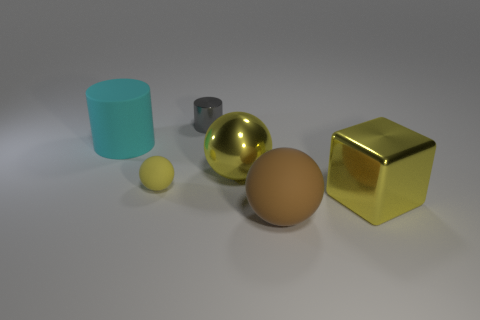How many things are either small objects that are behind the cyan thing or rubber objects that are to the right of the yellow shiny sphere?
Provide a short and direct response. 2. Are there an equal number of large cyan cylinders to the right of the block and large blocks that are on the right side of the brown thing?
Your answer should be compact. No. There is a big ball in front of the large block; what is its color?
Your answer should be compact. Brown. There is a small matte ball; is it the same color as the large metal thing right of the big yellow ball?
Make the answer very short. Yes. Are there fewer yellow metallic spheres than big cyan spheres?
Your answer should be very brief. No. There is a ball that is on the left side of the gray shiny object; does it have the same color as the large shiny block?
Offer a very short reply. Yes. What number of cyan rubber objects are the same size as the brown ball?
Ensure brevity in your answer.  1. Are there any other matte cylinders of the same color as the matte cylinder?
Your answer should be compact. No. Do the tiny gray object and the yellow cube have the same material?
Offer a terse response. Yes. What number of cyan rubber objects are the same shape as the tiny gray object?
Your answer should be compact. 1. 